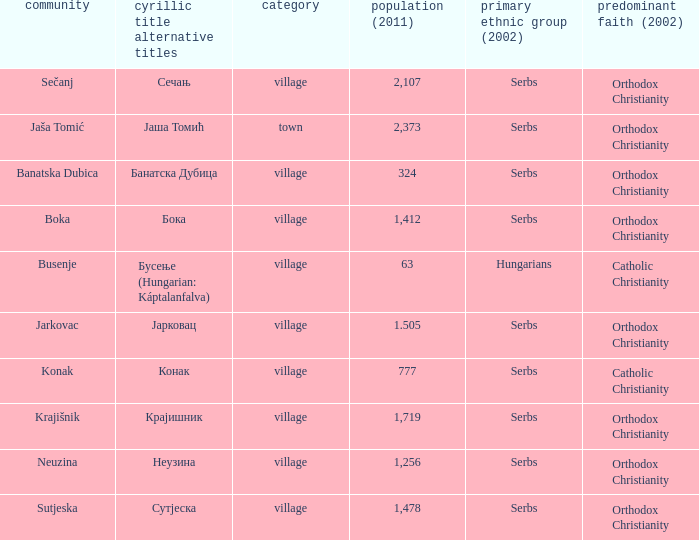What town has the population of 777? Конак. 